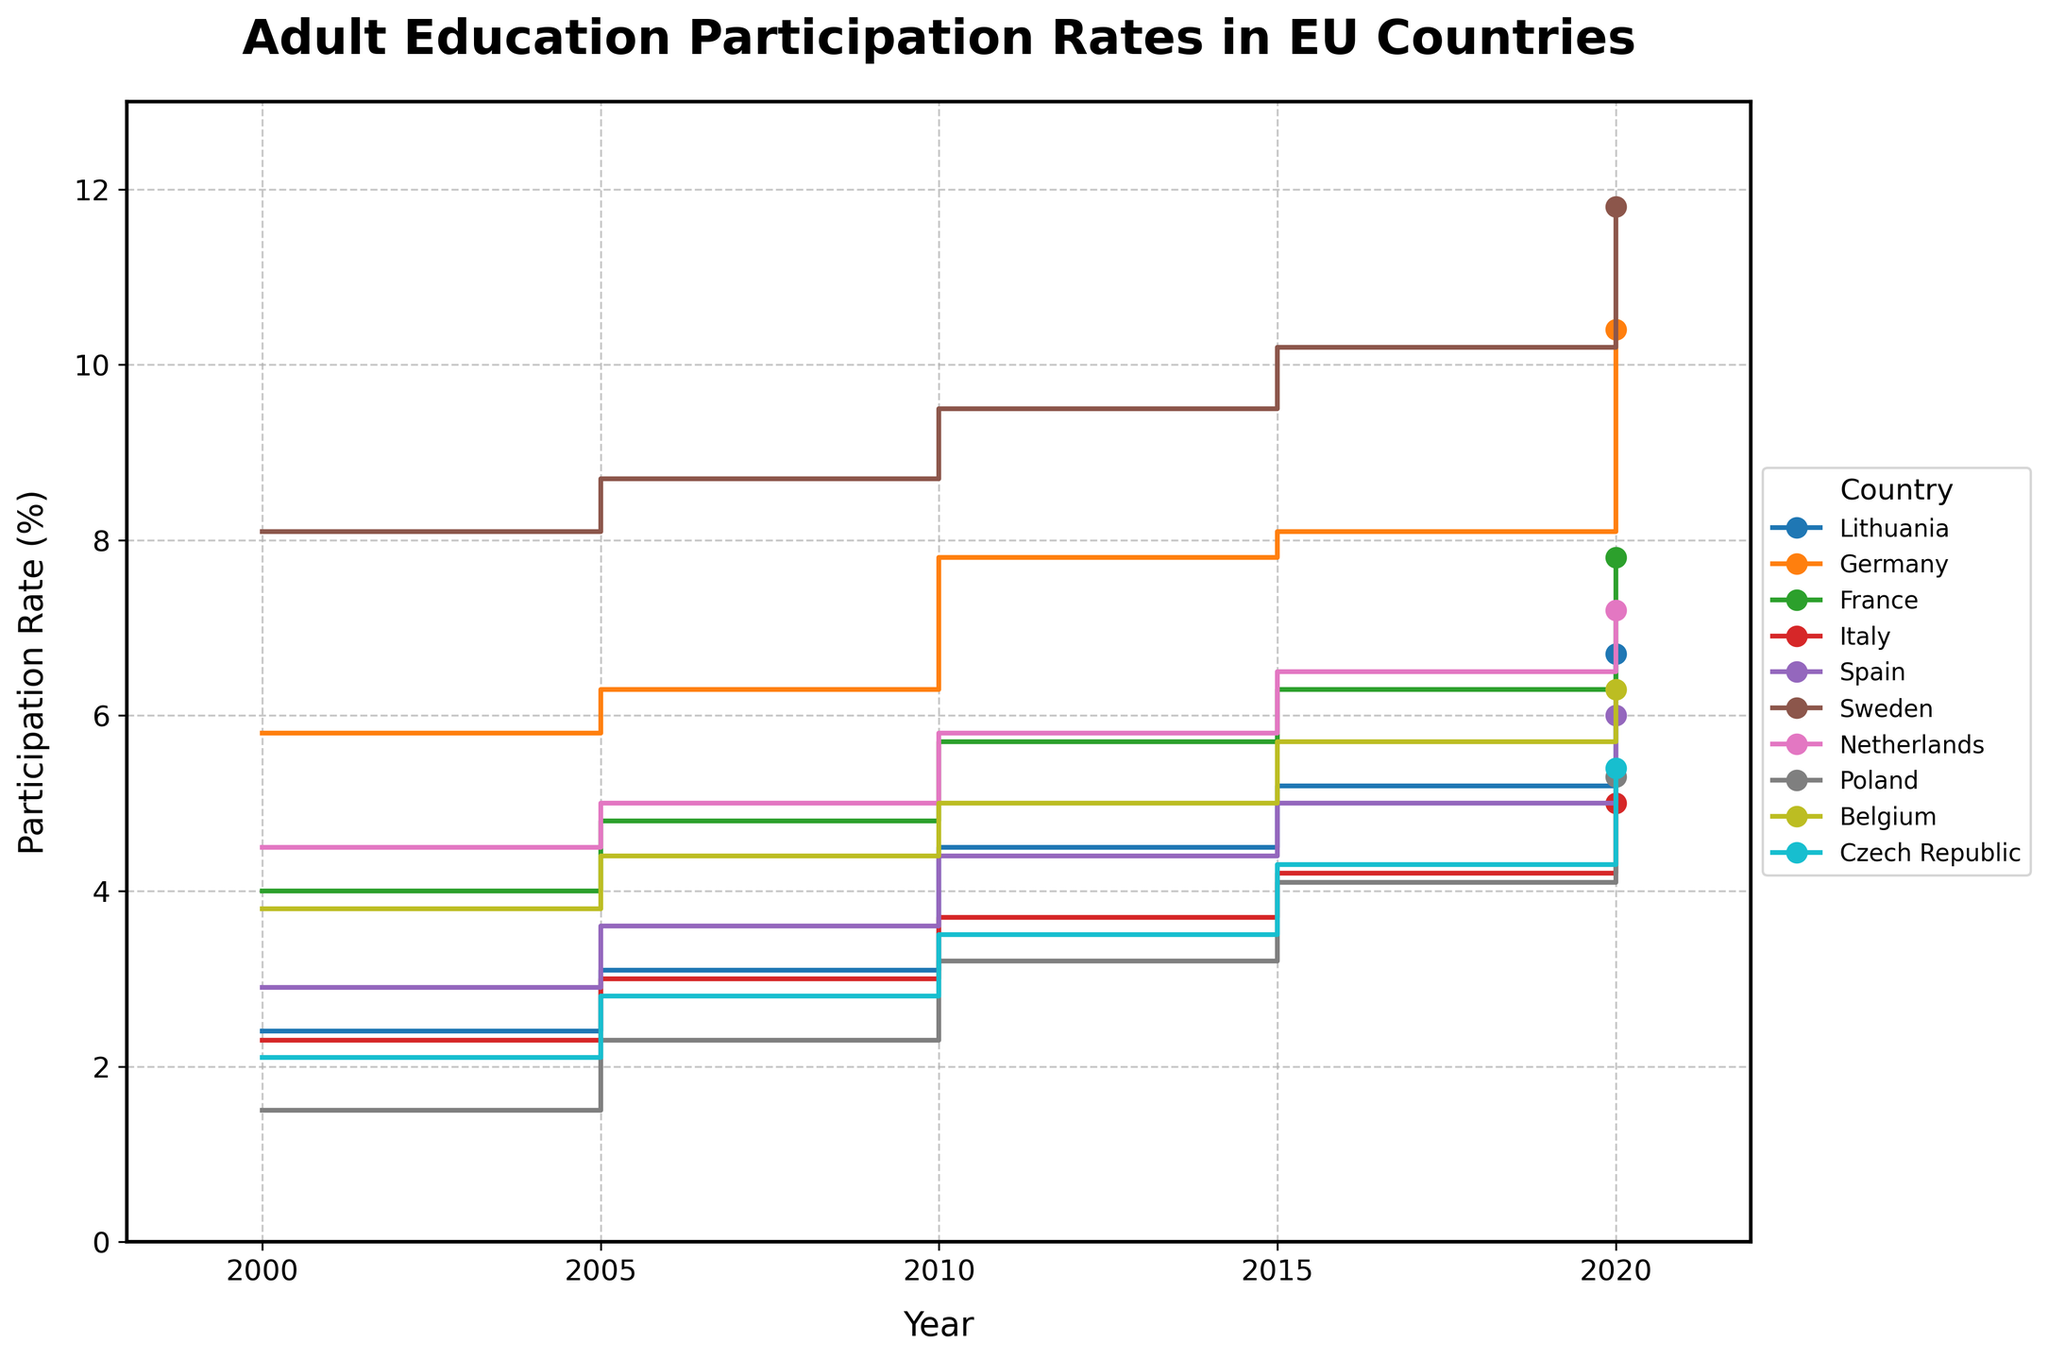Is the participation rate in adult education higher in Germany or Italy in 2020? First, locate the 2020 participation rates for both Germany and Italy on the figure. Germany's rate is 10.4%, and Italy's rate is 5.0%. Then compare the two values to determine which one is higher.
Answer: Germany Which country had the highest participation rate in 2000? Look at the participation rates for all countries in the year 2000. Sweden has the highest rate at 8.1%.
Answer: Sweden What is the general trend of adult education participation rates in Lithuania from 2000 to 2020? Observe the stair-step plot for Lithuania from 2000 to 2020. The participation rate consistently increases over these years, moving from 2.4% in 2000 to 6.7% in 2020.
Answer: Increasing By how much did the participation rate in Poland increase from 2000 to 2020? Identify the participation rates for Poland in 2000 (1.5%) and in 2020 (5.3%). Subtract the 2000 rate from the 2020 rate: 5.3% - 1.5% = 3.8%.
Answer: 3.8% Compare the adult education participation rates between France and Spain in 2015. Which country had a higher rate, and by how much? Find the 2015 rates for France (6.3%) and Spain (5.0%). France's rate is higher by 6.3% - 5.0% = 1.3%.
Answer: France, 1.3% What is the participation rate trend for adult education in Germany from 2000 to 2020? Examine the stair plot for Germany from 2000 (5.8%) to 2020 (10.4%). The rates show a general increasing trend over this period.
Answer: Increasing Which country had the smallest increase in adult education participation rate between 2000 and 2005? Calculate the rate increases for each country between 2000 and 2005. Italy had the smallest increase, going from 2.3% to 3.0%, an increase of 0.7%.
Answer: Italy Which three countries had the highest participation rates in 2020? Identify the 2020 participation rates for all countries and rank them. The top three are Sweden (11.8%), Germany (10.4%), and France (7.8%).
Answer: Sweden, Germany, France Is there any country where the adult education participation rate decreased in any of the recorded years? Check the stair-step plots for any country that shows a decrease from one year to the next. None of the countries show a decrease in participation rates; all are constant or increasing.
Answer: No 